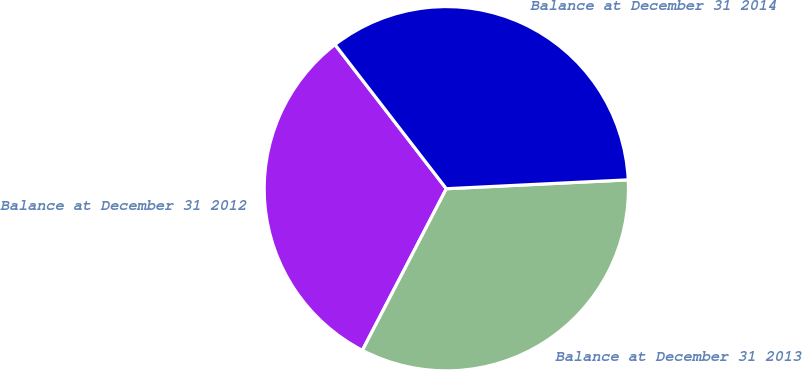Convert chart. <chart><loc_0><loc_0><loc_500><loc_500><pie_chart><fcel>Balance at December 31 2012<fcel>Balance at December 31 2013<fcel>Balance at December 31 2014<nl><fcel>31.91%<fcel>33.4%<fcel>34.69%<nl></chart> 